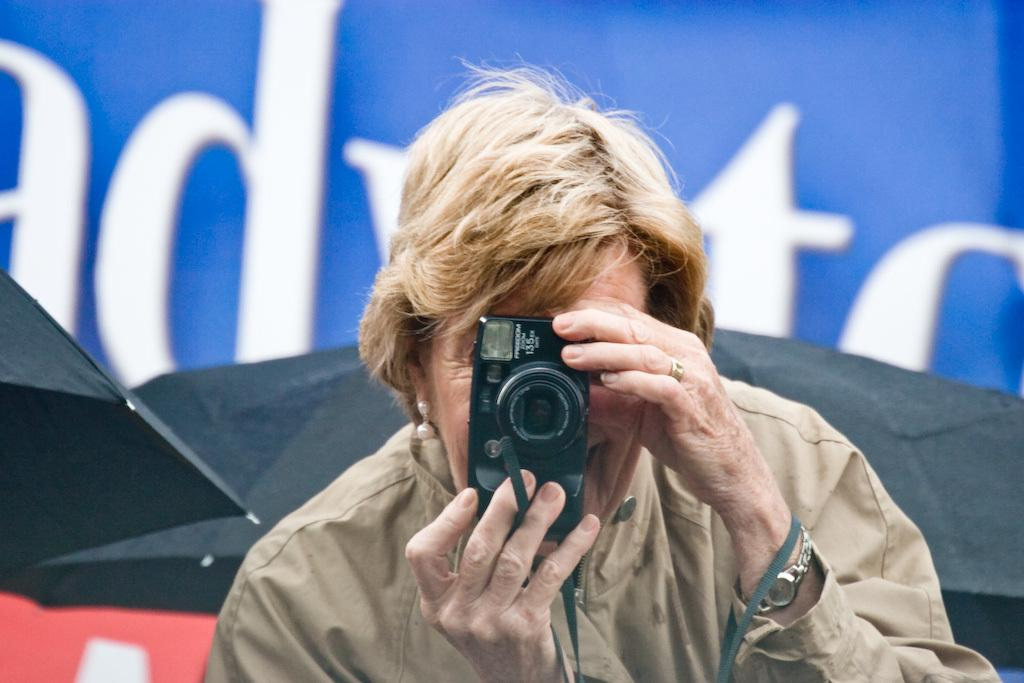Who is present in the image? There is a man in the image. What is the man doing in the image? The man is standing in the image. What object is the man holding in his hand? The man is holding a camera in his hand. What type of branch is the man holding in his hand? There is no branch present in the image; the man is holding a camera in his hand. 